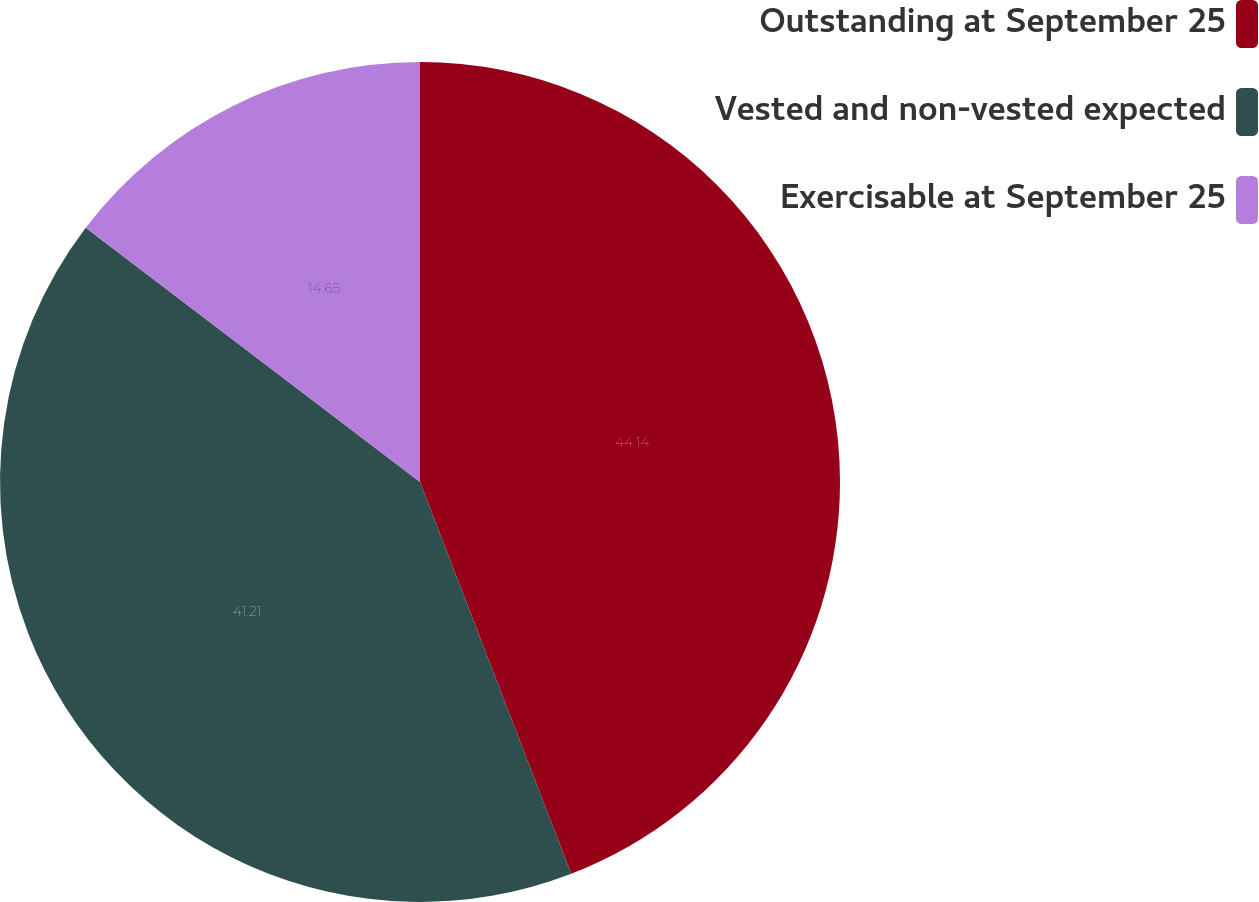Convert chart. <chart><loc_0><loc_0><loc_500><loc_500><pie_chart><fcel>Outstanding at September 25<fcel>Vested and non-vested expected<fcel>Exercisable at September 25<nl><fcel>44.14%<fcel>41.21%<fcel>14.65%<nl></chart> 